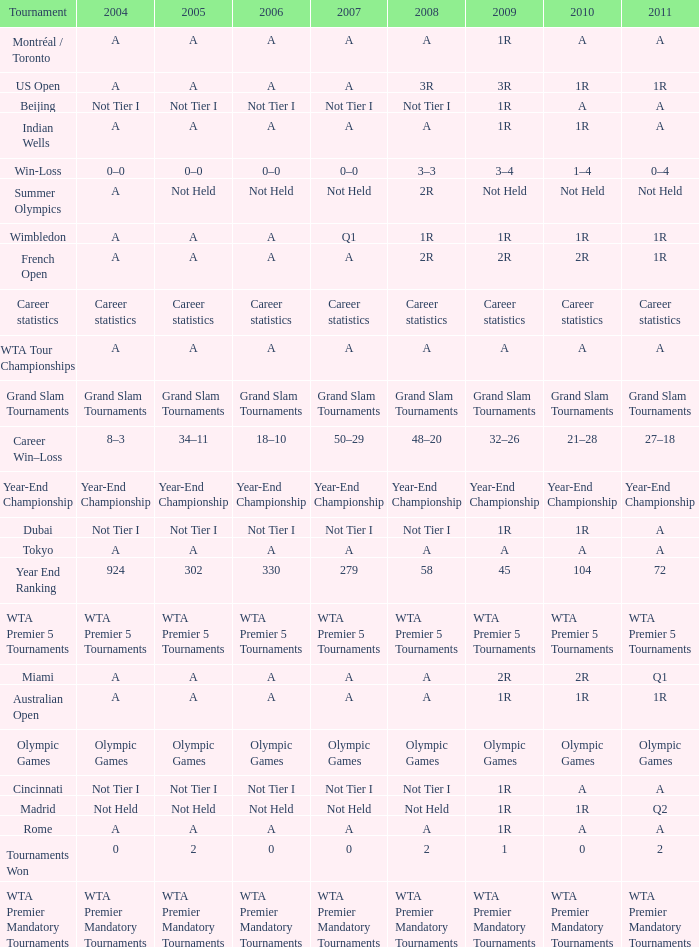What is 2011, when 2006 is "A", when 2008 is "A", and when Tournament is "Rome"? A. 